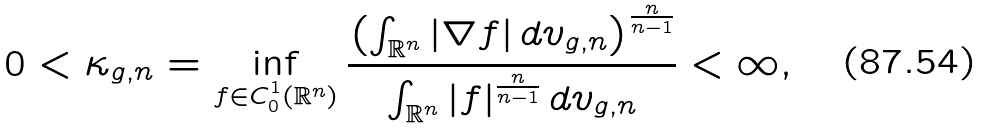<formula> <loc_0><loc_0><loc_500><loc_500>0 < \kappa _ { g , n } = \inf _ { f \in C ^ { 1 } _ { 0 } ( \mathbb { R } ^ { n } ) } \frac { \left ( \int _ { \mathbb { R } ^ { n } } | \nabla f | \, d v _ { g , n } \right ) ^ { \frac { n } { n - 1 } } } { \int _ { \mathbb { R } ^ { n } } | f | ^ { \frac { n } { n - 1 } } \, d v _ { g , n } } < \infty ,</formula> 